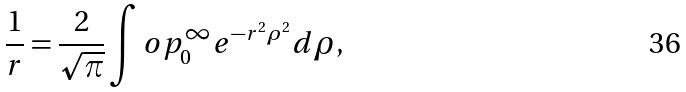Convert formula to latex. <formula><loc_0><loc_0><loc_500><loc_500>\frac { 1 } { r } = \frac { 2 } { \sqrt { \pi } } \int o p _ { 0 } ^ { \infty } e ^ { - r ^ { 2 } \rho ^ { 2 } } d \rho ,</formula> 